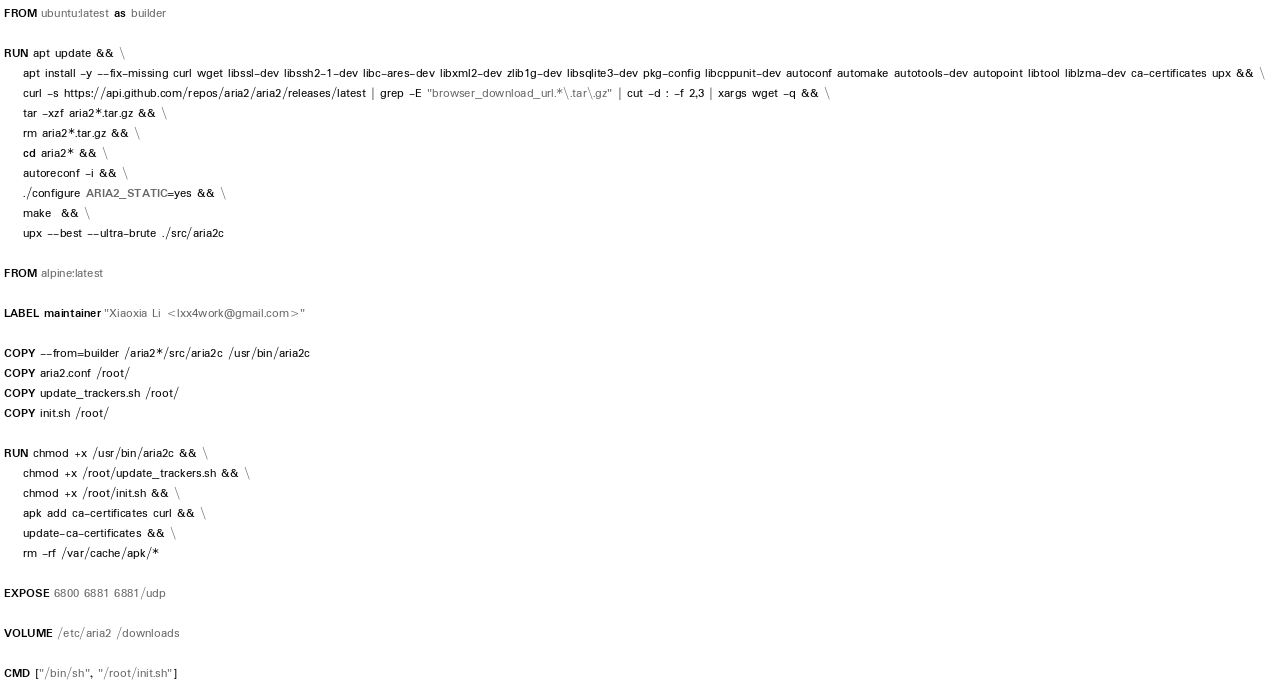Convert code to text. <code><loc_0><loc_0><loc_500><loc_500><_Dockerfile_>FROM ubuntu:latest as builder

RUN apt update && \
    apt install -y --fix-missing curl wget libssl-dev libssh2-1-dev libc-ares-dev libxml2-dev zlib1g-dev libsqlite3-dev pkg-config libcppunit-dev autoconf automake autotools-dev autopoint libtool liblzma-dev ca-certificates upx && \
    curl -s https://api.github.com/repos/aria2/aria2/releases/latest | grep -E "browser_download_url.*\.tar\.gz" | cut -d : -f 2,3 | xargs wget -q && \
    tar -xzf aria2*.tar.gz && \
    rm aria2*.tar.gz && \
    cd aria2* && \
    autoreconf -i && \
    ./configure ARIA2_STATIC=yes && \
    make  && \
    upx --best --ultra-brute ./src/aria2c 

FROM alpine:latest

LABEL maintainer "Xiaoxia Li <lxx4work@gmail.com>"

COPY --from=builder /aria2*/src/aria2c /usr/bin/aria2c
COPY aria2.conf /root/
COPY update_trackers.sh /root/
COPY init.sh /root/

RUN chmod +x /usr/bin/aria2c && \
    chmod +x /root/update_trackers.sh && \
    chmod +x /root/init.sh && \ 
    apk add ca-certificates curl && \
    update-ca-certificates && \ 
    rm -rf /var/cache/apk/* 

EXPOSE 6800 6881 6881/udp

VOLUME /etc/aria2 /downloads

CMD ["/bin/sh", "/root/init.sh"]
</code> 